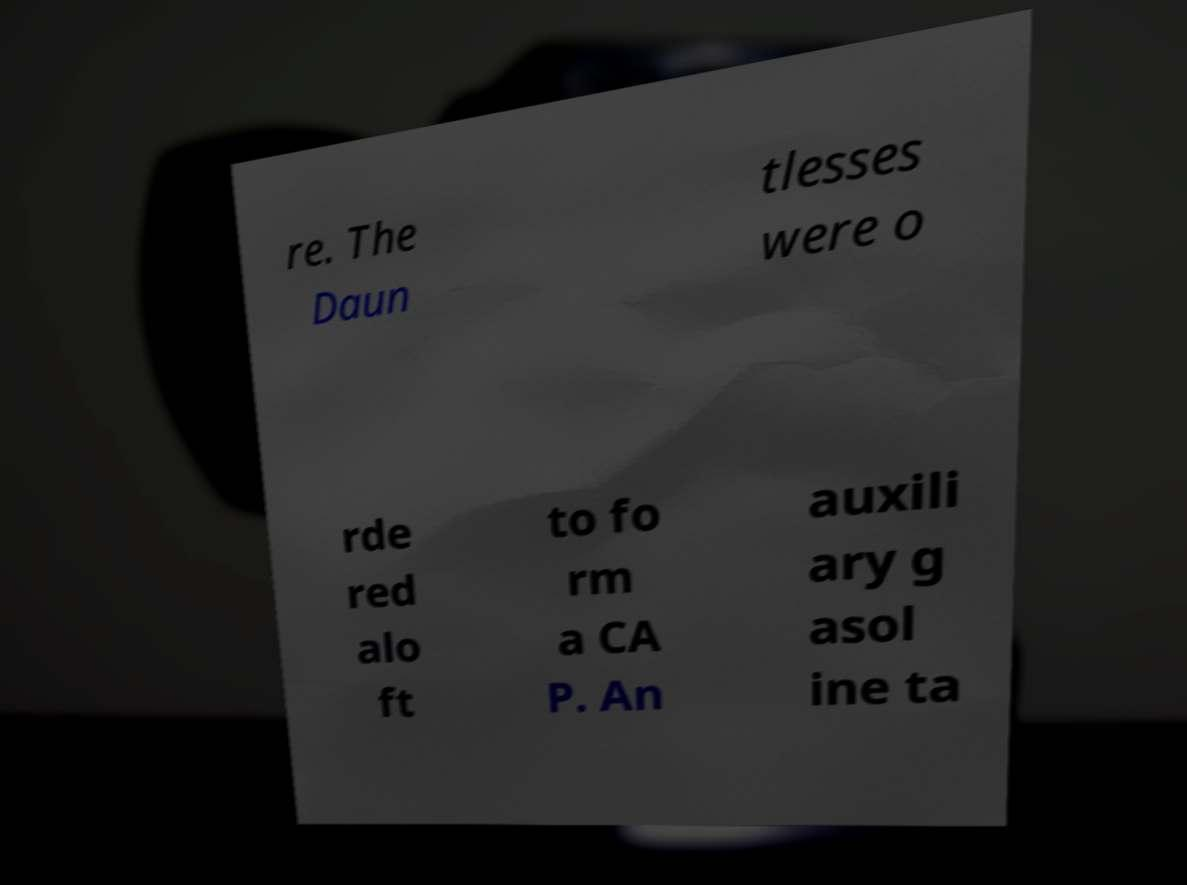Could you assist in decoding the text presented in this image and type it out clearly? re. The Daun tlesses were o rde red alo ft to fo rm a CA P. An auxili ary g asol ine ta 